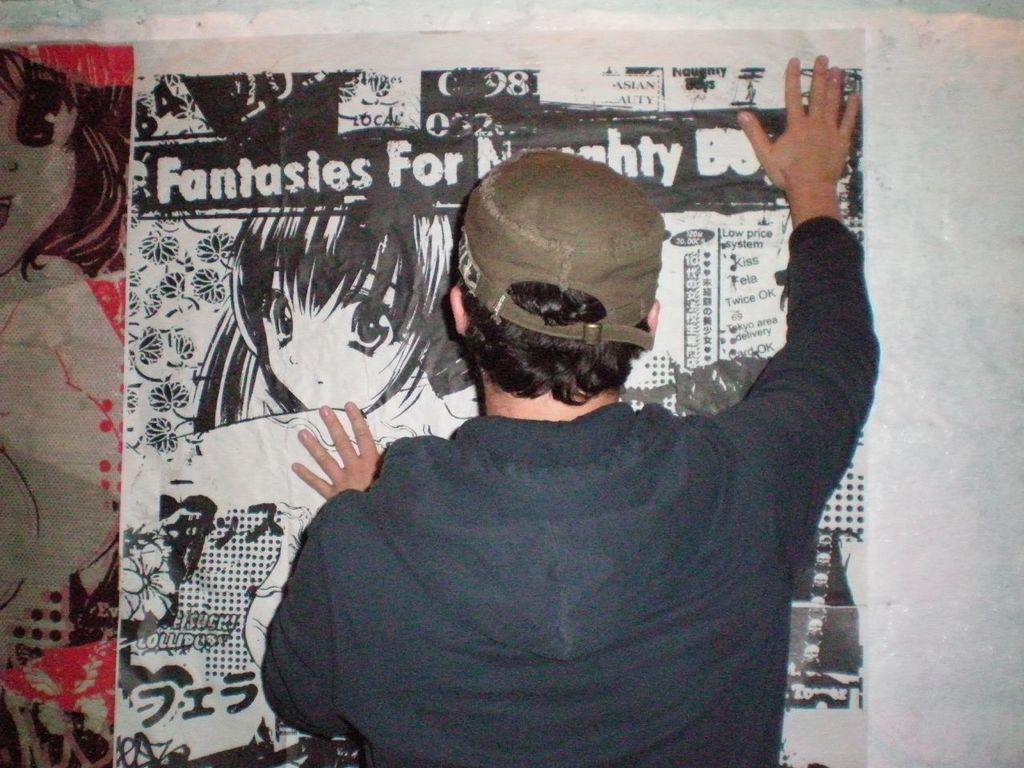Describe this image in one or two sentences. In this image we can see a person wearing a cap and holding a poster on the wall, in the poster we can see a few pictures and some text. 